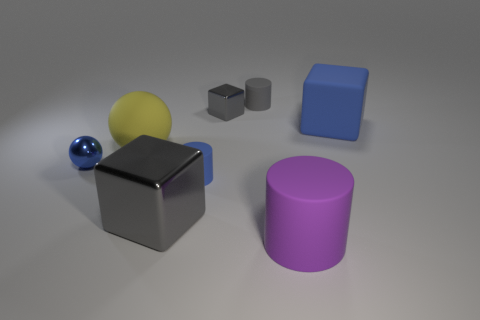Is the shape of the large blue object the same as the big purple rubber thing?
Give a very brief answer. No. How many big matte objects are both behind the big purple thing and in front of the small blue shiny ball?
Make the answer very short. 0. Are there the same number of tiny gray shiny blocks right of the gray rubber thing and large gray metallic blocks that are behind the purple thing?
Provide a short and direct response. No. Is the size of the cube to the right of the large purple thing the same as the blue matte thing on the left side of the purple rubber cylinder?
Give a very brief answer. No. What material is the big thing that is behind the big gray shiny thing and on the right side of the yellow matte ball?
Provide a succinct answer. Rubber. Is the number of blue things less than the number of large blue cubes?
Ensure brevity in your answer.  No. How big is the metallic block behind the cube that is right of the big cylinder?
Make the answer very short. Small. The blue object on the right side of the large rubber cylinder left of the big cube on the right side of the tiny gray metal object is what shape?
Keep it short and to the point. Cube. The big cube that is the same material as the big purple thing is what color?
Provide a short and direct response. Blue. What color is the small object that is on the right side of the gray cube right of the big block that is in front of the metallic sphere?
Provide a short and direct response. Gray. 